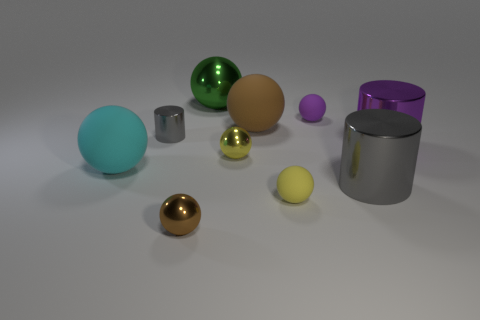How many other objects are the same size as the yellow rubber thing?
Make the answer very short. 4. There is a brown ball on the left side of the big green metal sphere; does it have the same size as the cylinder to the left of the purple rubber thing?
Your answer should be compact. Yes. What number of things are either big green cylinders or large metallic objects that are behind the cyan ball?
Offer a terse response. 2. How big is the rubber object on the left side of the large brown ball?
Keep it short and to the point. Large. Are there fewer small purple rubber things in front of the small yellow matte thing than things that are in front of the green sphere?
Offer a terse response. Yes. What is the tiny sphere that is both behind the big gray shiny thing and in front of the big brown matte sphere made of?
Ensure brevity in your answer.  Metal. The tiny matte object that is in front of the gray metal object that is on the left side of the small yellow matte thing is what shape?
Give a very brief answer. Sphere. What number of purple things are large shiny balls or small metal cubes?
Offer a very short reply. 0. Are there any tiny brown spheres in front of the purple rubber thing?
Offer a terse response. Yes. The brown shiny object is what size?
Ensure brevity in your answer.  Small. 